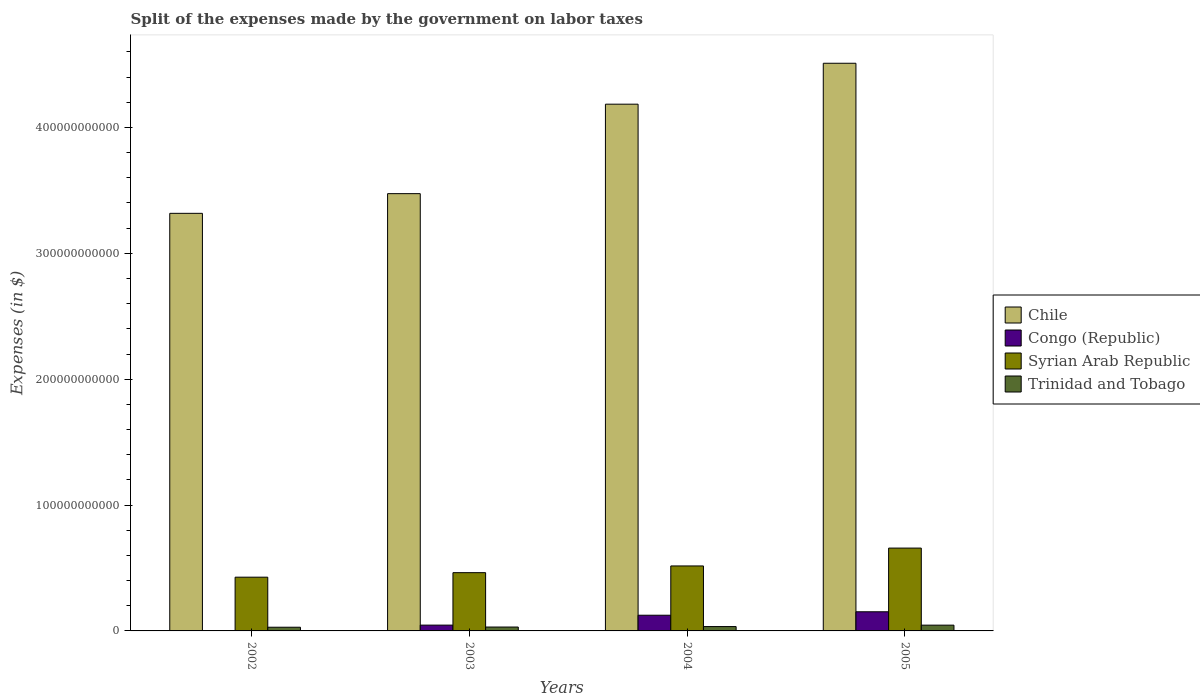How many groups of bars are there?
Give a very brief answer. 4. Are the number of bars on each tick of the X-axis equal?
Provide a succinct answer. Yes. How many bars are there on the 4th tick from the right?
Offer a terse response. 4. In how many cases, is the number of bars for a given year not equal to the number of legend labels?
Make the answer very short. 0. What is the expenses made by the government on labor taxes in Trinidad and Tobago in 2005?
Provide a succinct answer. 4.59e+09. Across all years, what is the maximum expenses made by the government on labor taxes in Chile?
Your answer should be very brief. 4.51e+11. Across all years, what is the minimum expenses made by the government on labor taxes in Syrian Arab Republic?
Your response must be concise. 4.27e+1. In which year was the expenses made by the government on labor taxes in Syrian Arab Republic minimum?
Offer a very short reply. 2002. What is the total expenses made by the government on labor taxes in Trinidad and Tobago in the graph?
Give a very brief answer. 1.41e+1. What is the difference between the expenses made by the government on labor taxes in Congo (Republic) in 2002 and that in 2005?
Keep it short and to the point. -1.49e+1. What is the difference between the expenses made by the government on labor taxes in Chile in 2003 and the expenses made by the government on labor taxes in Trinidad and Tobago in 2004?
Your answer should be compact. 3.44e+11. What is the average expenses made by the government on labor taxes in Syrian Arab Republic per year?
Your answer should be very brief. 5.16e+1. In the year 2004, what is the difference between the expenses made by the government on labor taxes in Congo (Republic) and expenses made by the government on labor taxes in Syrian Arab Republic?
Your answer should be very brief. -3.92e+1. In how many years, is the expenses made by the government on labor taxes in Trinidad and Tobago greater than 300000000000 $?
Make the answer very short. 0. What is the ratio of the expenses made by the government on labor taxes in Trinidad and Tobago in 2004 to that in 2005?
Provide a short and direct response. 0.75. Is the expenses made by the government on labor taxes in Chile in 2002 less than that in 2003?
Your answer should be very brief. Yes. What is the difference between the highest and the second highest expenses made by the government on labor taxes in Syrian Arab Republic?
Offer a terse response. 1.42e+1. What is the difference between the highest and the lowest expenses made by the government on labor taxes in Trinidad and Tobago?
Give a very brief answer. 1.66e+09. In how many years, is the expenses made by the government on labor taxes in Trinidad and Tobago greater than the average expenses made by the government on labor taxes in Trinidad and Tobago taken over all years?
Make the answer very short. 1. Is it the case that in every year, the sum of the expenses made by the government on labor taxes in Chile and expenses made by the government on labor taxes in Congo (Republic) is greater than the sum of expenses made by the government on labor taxes in Trinidad and Tobago and expenses made by the government on labor taxes in Syrian Arab Republic?
Keep it short and to the point. Yes. What does the 4th bar from the left in 2005 represents?
Provide a succinct answer. Trinidad and Tobago. What does the 1st bar from the right in 2005 represents?
Your response must be concise. Trinidad and Tobago. Are all the bars in the graph horizontal?
Give a very brief answer. No. What is the difference between two consecutive major ticks on the Y-axis?
Offer a terse response. 1.00e+11. Are the values on the major ticks of Y-axis written in scientific E-notation?
Your answer should be very brief. No. Does the graph contain any zero values?
Ensure brevity in your answer.  No. Where does the legend appear in the graph?
Ensure brevity in your answer.  Center right. What is the title of the graph?
Your answer should be compact. Split of the expenses made by the government on labor taxes. Does "South Asia" appear as one of the legend labels in the graph?
Keep it short and to the point. No. What is the label or title of the X-axis?
Make the answer very short. Years. What is the label or title of the Y-axis?
Give a very brief answer. Expenses (in $). What is the Expenses (in $) of Chile in 2002?
Your answer should be compact. 3.32e+11. What is the Expenses (in $) of Congo (Republic) in 2002?
Provide a succinct answer. 3.12e+08. What is the Expenses (in $) of Syrian Arab Republic in 2002?
Ensure brevity in your answer.  4.27e+1. What is the Expenses (in $) of Trinidad and Tobago in 2002?
Your answer should be very brief. 2.93e+09. What is the Expenses (in $) of Chile in 2003?
Give a very brief answer. 3.47e+11. What is the Expenses (in $) of Congo (Republic) in 2003?
Provide a succinct answer. 4.61e+09. What is the Expenses (in $) in Syrian Arab Republic in 2003?
Your answer should be very brief. 4.63e+1. What is the Expenses (in $) in Trinidad and Tobago in 2003?
Offer a terse response. 3.09e+09. What is the Expenses (in $) in Chile in 2004?
Make the answer very short. 4.18e+11. What is the Expenses (in $) in Congo (Republic) in 2004?
Your answer should be compact. 1.25e+1. What is the Expenses (in $) of Syrian Arab Republic in 2004?
Your answer should be compact. 5.16e+1. What is the Expenses (in $) in Trinidad and Tobago in 2004?
Keep it short and to the point. 3.46e+09. What is the Expenses (in $) in Chile in 2005?
Provide a short and direct response. 4.51e+11. What is the Expenses (in $) of Congo (Republic) in 2005?
Give a very brief answer. 1.52e+1. What is the Expenses (in $) in Syrian Arab Republic in 2005?
Give a very brief answer. 6.58e+1. What is the Expenses (in $) in Trinidad and Tobago in 2005?
Provide a short and direct response. 4.59e+09. Across all years, what is the maximum Expenses (in $) in Chile?
Your response must be concise. 4.51e+11. Across all years, what is the maximum Expenses (in $) in Congo (Republic)?
Your answer should be very brief. 1.52e+1. Across all years, what is the maximum Expenses (in $) in Syrian Arab Republic?
Provide a short and direct response. 6.58e+1. Across all years, what is the maximum Expenses (in $) of Trinidad and Tobago?
Your answer should be very brief. 4.59e+09. Across all years, what is the minimum Expenses (in $) in Chile?
Give a very brief answer. 3.32e+11. Across all years, what is the minimum Expenses (in $) in Congo (Republic)?
Offer a very short reply. 3.12e+08. Across all years, what is the minimum Expenses (in $) in Syrian Arab Republic?
Make the answer very short. 4.27e+1. Across all years, what is the minimum Expenses (in $) in Trinidad and Tobago?
Your answer should be very brief. 2.93e+09. What is the total Expenses (in $) of Chile in the graph?
Offer a terse response. 1.55e+12. What is the total Expenses (in $) of Congo (Republic) in the graph?
Make the answer very short. 3.26e+1. What is the total Expenses (in $) in Syrian Arab Republic in the graph?
Your answer should be compact. 2.06e+11. What is the total Expenses (in $) in Trinidad and Tobago in the graph?
Keep it short and to the point. 1.41e+1. What is the difference between the Expenses (in $) of Chile in 2002 and that in 2003?
Ensure brevity in your answer.  -1.56e+1. What is the difference between the Expenses (in $) of Congo (Republic) in 2002 and that in 2003?
Offer a very short reply. -4.30e+09. What is the difference between the Expenses (in $) of Syrian Arab Republic in 2002 and that in 2003?
Keep it short and to the point. -3.59e+09. What is the difference between the Expenses (in $) in Trinidad and Tobago in 2002 and that in 2003?
Your answer should be very brief. -1.53e+08. What is the difference between the Expenses (in $) in Chile in 2002 and that in 2004?
Give a very brief answer. -8.67e+1. What is the difference between the Expenses (in $) in Congo (Republic) in 2002 and that in 2004?
Offer a very short reply. -1.22e+1. What is the difference between the Expenses (in $) of Syrian Arab Republic in 2002 and that in 2004?
Keep it short and to the point. -8.93e+09. What is the difference between the Expenses (in $) in Trinidad and Tobago in 2002 and that in 2004?
Your answer should be compact. -5.26e+08. What is the difference between the Expenses (in $) in Chile in 2002 and that in 2005?
Your answer should be very brief. -1.19e+11. What is the difference between the Expenses (in $) in Congo (Republic) in 2002 and that in 2005?
Your response must be concise. -1.49e+1. What is the difference between the Expenses (in $) in Syrian Arab Republic in 2002 and that in 2005?
Your answer should be compact. -2.31e+1. What is the difference between the Expenses (in $) in Trinidad and Tobago in 2002 and that in 2005?
Your answer should be very brief. -1.66e+09. What is the difference between the Expenses (in $) in Chile in 2003 and that in 2004?
Your answer should be very brief. -7.11e+1. What is the difference between the Expenses (in $) of Congo (Republic) in 2003 and that in 2004?
Keep it short and to the point. -7.85e+09. What is the difference between the Expenses (in $) in Syrian Arab Republic in 2003 and that in 2004?
Make the answer very short. -5.34e+09. What is the difference between the Expenses (in $) of Trinidad and Tobago in 2003 and that in 2004?
Offer a terse response. -3.72e+08. What is the difference between the Expenses (in $) in Chile in 2003 and that in 2005?
Your answer should be compact. -1.04e+11. What is the difference between the Expenses (in $) of Congo (Republic) in 2003 and that in 2005?
Ensure brevity in your answer.  -1.06e+1. What is the difference between the Expenses (in $) in Syrian Arab Republic in 2003 and that in 2005?
Provide a short and direct response. -1.95e+1. What is the difference between the Expenses (in $) in Trinidad and Tobago in 2003 and that in 2005?
Keep it short and to the point. -1.50e+09. What is the difference between the Expenses (in $) of Chile in 2004 and that in 2005?
Keep it short and to the point. -3.25e+1. What is the difference between the Expenses (in $) in Congo (Republic) in 2004 and that in 2005?
Provide a short and direct response. -2.75e+09. What is the difference between the Expenses (in $) of Syrian Arab Republic in 2004 and that in 2005?
Your answer should be compact. -1.42e+1. What is the difference between the Expenses (in $) of Trinidad and Tobago in 2004 and that in 2005?
Give a very brief answer. -1.13e+09. What is the difference between the Expenses (in $) of Chile in 2002 and the Expenses (in $) of Congo (Republic) in 2003?
Your answer should be very brief. 3.27e+11. What is the difference between the Expenses (in $) in Chile in 2002 and the Expenses (in $) in Syrian Arab Republic in 2003?
Provide a succinct answer. 2.85e+11. What is the difference between the Expenses (in $) of Chile in 2002 and the Expenses (in $) of Trinidad and Tobago in 2003?
Ensure brevity in your answer.  3.29e+11. What is the difference between the Expenses (in $) in Congo (Republic) in 2002 and the Expenses (in $) in Syrian Arab Republic in 2003?
Give a very brief answer. -4.60e+1. What is the difference between the Expenses (in $) in Congo (Republic) in 2002 and the Expenses (in $) in Trinidad and Tobago in 2003?
Give a very brief answer. -2.78e+09. What is the difference between the Expenses (in $) in Syrian Arab Republic in 2002 and the Expenses (in $) in Trinidad and Tobago in 2003?
Make the answer very short. 3.96e+1. What is the difference between the Expenses (in $) of Chile in 2002 and the Expenses (in $) of Congo (Republic) in 2004?
Make the answer very short. 3.19e+11. What is the difference between the Expenses (in $) of Chile in 2002 and the Expenses (in $) of Syrian Arab Republic in 2004?
Your answer should be compact. 2.80e+11. What is the difference between the Expenses (in $) of Chile in 2002 and the Expenses (in $) of Trinidad and Tobago in 2004?
Offer a terse response. 3.28e+11. What is the difference between the Expenses (in $) of Congo (Republic) in 2002 and the Expenses (in $) of Syrian Arab Republic in 2004?
Provide a succinct answer. -5.13e+1. What is the difference between the Expenses (in $) of Congo (Republic) in 2002 and the Expenses (in $) of Trinidad and Tobago in 2004?
Offer a terse response. -3.15e+09. What is the difference between the Expenses (in $) in Syrian Arab Republic in 2002 and the Expenses (in $) in Trinidad and Tobago in 2004?
Your answer should be compact. 3.92e+1. What is the difference between the Expenses (in $) of Chile in 2002 and the Expenses (in $) of Congo (Republic) in 2005?
Keep it short and to the point. 3.17e+11. What is the difference between the Expenses (in $) in Chile in 2002 and the Expenses (in $) in Syrian Arab Republic in 2005?
Provide a succinct answer. 2.66e+11. What is the difference between the Expenses (in $) of Chile in 2002 and the Expenses (in $) of Trinidad and Tobago in 2005?
Your answer should be compact. 3.27e+11. What is the difference between the Expenses (in $) of Congo (Republic) in 2002 and the Expenses (in $) of Syrian Arab Republic in 2005?
Your response must be concise. -6.55e+1. What is the difference between the Expenses (in $) of Congo (Republic) in 2002 and the Expenses (in $) of Trinidad and Tobago in 2005?
Ensure brevity in your answer.  -4.28e+09. What is the difference between the Expenses (in $) of Syrian Arab Republic in 2002 and the Expenses (in $) of Trinidad and Tobago in 2005?
Give a very brief answer. 3.81e+1. What is the difference between the Expenses (in $) in Chile in 2003 and the Expenses (in $) in Congo (Republic) in 2004?
Your response must be concise. 3.35e+11. What is the difference between the Expenses (in $) of Chile in 2003 and the Expenses (in $) of Syrian Arab Republic in 2004?
Provide a succinct answer. 2.96e+11. What is the difference between the Expenses (in $) of Chile in 2003 and the Expenses (in $) of Trinidad and Tobago in 2004?
Your response must be concise. 3.44e+11. What is the difference between the Expenses (in $) of Congo (Republic) in 2003 and the Expenses (in $) of Syrian Arab Republic in 2004?
Keep it short and to the point. -4.70e+1. What is the difference between the Expenses (in $) of Congo (Republic) in 2003 and the Expenses (in $) of Trinidad and Tobago in 2004?
Offer a terse response. 1.15e+09. What is the difference between the Expenses (in $) in Syrian Arab Republic in 2003 and the Expenses (in $) in Trinidad and Tobago in 2004?
Provide a short and direct response. 4.28e+1. What is the difference between the Expenses (in $) in Chile in 2003 and the Expenses (in $) in Congo (Republic) in 2005?
Offer a terse response. 3.32e+11. What is the difference between the Expenses (in $) in Chile in 2003 and the Expenses (in $) in Syrian Arab Republic in 2005?
Make the answer very short. 2.82e+11. What is the difference between the Expenses (in $) in Chile in 2003 and the Expenses (in $) in Trinidad and Tobago in 2005?
Provide a short and direct response. 3.43e+11. What is the difference between the Expenses (in $) of Congo (Republic) in 2003 and the Expenses (in $) of Syrian Arab Republic in 2005?
Ensure brevity in your answer.  -6.12e+1. What is the difference between the Expenses (in $) in Congo (Republic) in 2003 and the Expenses (in $) in Trinidad and Tobago in 2005?
Offer a terse response. 2.38e+07. What is the difference between the Expenses (in $) in Syrian Arab Republic in 2003 and the Expenses (in $) in Trinidad and Tobago in 2005?
Keep it short and to the point. 4.17e+1. What is the difference between the Expenses (in $) in Chile in 2004 and the Expenses (in $) in Congo (Republic) in 2005?
Keep it short and to the point. 4.03e+11. What is the difference between the Expenses (in $) in Chile in 2004 and the Expenses (in $) in Syrian Arab Republic in 2005?
Your response must be concise. 3.53e+11. What is the difference between the Expenses (in $) in Chile in 2004 and the Expenses (in $) in Trinidad and Tobago in 2005?
Your answer should be compact. 4.14e+11. What is the difference between the Expenses (in $) in Congo (Republic) in 2004 and the Expenses (in $) in Syrian Arab Republic in 2005?
Provide a short and direct response. -5.33e+1. What is the difference between the Expenses (in $) in Congo (Republic) in 2004 and the Expenses (in $) in Trinidad and Tobago in 2005?
Keep it short and to the point. 7.87e+09. What is the difference between the Expenses (in $) in Syrian Arab Republic in 2004 and the Expenses (in $) in Trinidad and Tobago in 2005?
Your answer should be compact. 4.70e+1. What is the average Expenses (in $) of Chile per year?
Offer a terse response. 3.87e+11. What is the average Expenses (in $) in Congo (Republic) per year?
Your answer should be very brief. 8.15e+09. What is the average Expenses (in $) in Syrian Arab Republic per year?
Provide a succinct answer. 5.16e+1. What is the average Expenses (in $) in Trinidad and Tobago per year?
Offer a terse response. 3.52e+09. In the year 2002, what is the difference between the Expenses (in $) of Chile and Expenses (in $) of Congo (Republic)?
Give a very brief answer. 3.31e+11. In the year 2002, what is the difference between the Expenses (in $) in Chile and Expenses (in $) in Syrian Arab Republic?
Your answer should be compact. 2.89e+11. In the year 2002, what is the difference between the Expenses (in $) in Chile and Expenses (in $) in Trinidad and Tobago?
Your answer should be very brief. 3.29e+11. In the year 2002, what is the difference between the Expenses (in $) of Congo (Republic) and Expenses (in $) of Syrian Arab Republic?
Your answer should be very brief. -4.24e+1. In the year 2002, what is the difference between the Expenses (in $) of Congo (Republic) and Expenses (in $) of Trinidad and Tobago?
Provide a succinct answer. -2.62e+09. In the year 2002, what is the difference between the Expenses (in $) in Syrian Arab Republic and Expenses (in $) in Trinidad and Tobago?
Provide a short and direct response. 3.98e+1. In the year 2003, what is the difference between the Expenses (in $) in Chile and Expenses (in $) in Congo (Republic)?
Provide a succinct answer. 3.43e+11. In the year 2003, what is the difference between the Expenses (in $) of Chile and Expenses (in $) of Syrian Arab Republic?
Provide a short and direct response. 3.01e+11. In the year 2003, what is the difference between the Expenses (in $) in Chile and Expenses (in $) in Trinidad and Tobago?
Make the answer very short. 3.44e+11. In the year 2003, what is the difference between the Expenses (in $) of Congo (Republic) and Expenses (in $) of Syrian Arab Republic?
Ensure brevity in your answer.  -4.17e+1. In the year 2003, what is the difference between the Expenses (in $) of Congo (Republic) and Expenses (in $) of Trinidad and Tobago?
Provide a succinct answer. 1.53e+09. In the year 2003, what is the difference between the Expenses (in $) of Syrian Arab Republic and Expenses (in $) of Trinidad and Tobago?
Make the answer very short. 4.32e+1. In the year 2004, what is the difference between the Expenses (in $) of Chile and Expenses (in $) of Congo (Republic)?
Ensure brevity in your answer.  4.06e+11. In the year 2004, what is the difference between the Expenses (in $) of Chile and Expenses (in $) of Syrian Arab Republic?
Your answer should be compact. 3.67e+11. In the year 2004, what is the difference between the Expenses (in $) of Chile and Expenses (in $) of Trinidad and Tobago?
Keep it short and to the point. 4.15e+11. In the year 2004, what is the difference between the Expenses (in $) in Congo (Republic) and Expenses (in $) in Syrian Arab Republic?
Your answer should be very brief. -3.92e+1. In the year 2004, what is the difference between the Expenses (in $) in Congo (Republic) and Expenses (in $) in Trinidad and Tobago?
Provide a succinct answer. 9.00e+09. In the year 2004, what is the difference between the Expenses (in $) in Syrian Arab Republic and Expenses (in $) in Trinidad and Tobago?
Make the answer very short. 4.82e+1. In the year 2005, what is the difference between the Expenses (in $) in Chile and Expenses (in $) in Congo (Republic)?
Give a very brief answer. 4.36e+11. In the year 2005, what is the difference between the Expenses (in $) of Chile and Expenses (in $) of Syrian Arab Republic?
Provide a short and direct response. 3.85e+11. In the year 2005, what is the difference between the Expenses (in $) of Chile and Expenses (in $) of Trinidad and Tobago?
Keep it short and to the point. 4.46e+11. In the year 2005, what is the difference between the Expenses (in $) in Congo (Republic) and Expenses (in $) in Syrian Arab Republic?
Provide a short and direct response. -5.06e+1. In the year 2005, what is the difference between the Expenses (in $) in Congo (Republic) and Expenses (in $) in Trinidad and Tobago?
Give a very brief answer. 1.06e+1. In the year 2005, what is the difference between the Expenses (in $) in Syrian Arab Republic and Expenses (in $) in Trinidad and Tobago?
Your response must be concise. 6.12e+1. What is the ratio of the Expenses (in $) of Chile in 2002 to that in 2003?
Your response must be concise. 0.95. What is the ratio of the Expenses (in $) of Congo (Republic) in 2002 to that in 2003?
Provide a succinct answer. 0.07. What is the ratio of the Expenses (in $) of Syrian Arab Republic in 2002 to that in 2003?
Your response must be concise. 0.92. What is the ratio of the Expenses (in $) of Trinidad and Tobago in 2002 to that in 2003?
Make the answer very short. 0.95. What is the ratio of the Expenses (in $) in Chile in 2002 to that in 2004?
Keep it short and to the point. 0.79. What is the ratio of the Expenses (in $) of Congo (Republic) in 2002 to that in 2004?
Offer a terse response. 0.03. What is the ratio of the Expenses (in $) of Syrian Arab Republic in 2002 to that in 2004?
Make the answer very short. 0.83. What is the ratio of the Expenses (in $) of Trinidad and Tobago in 2002 to that in 2004?
Give a very brief answer. 0.85. What is the ratio of the Expenses (in $) in Chile in 2002 to that in 2005?
Provide a short and direct response. 0.74. What is the ratio of the Expenses (in $) in Congo (Republic) in 2002 to that in 2005?
Your response must be concise. 0.02. What is the ratio of the Expenses (in $) in Syrian Arab Republic in 2002 to that in 2005?
Offer a terse response. 0.65. What is the ratio of the Expenses (in $) of Trinidad and Tobago in 2002 to that in 2005?
Your response must be concise. 0.64. What is the ratio of the Expenses (in $) in Chile in 2003 to that in 2004?
Make the answer very short. 0.83. What is the ratio of the Expenses (in $) in Congo (Republic) in 2003 to that in 2004?
Ensure brevity in your answer.  0.37. What is the ratio of the Expenses (in $) of Syrian Arab Republic in 2003 to that in 2004?
Your answer should be compact. 0.9. What is the ratio of the Expenses (in $) in Trinidad and Tobago in 2003 to that in 2004?
Offer a terse response. 0.89. What is the ratio of the Expenses (in $) in Chile in 2003 to that in 2005?
Your answer should be compact. 0.77. What is the ratio of the Expenses (in $) in Congo (Republic) in 2003 to that in 2005?
Make the answer very short. 0.3. What is the ratio of the Expenses (in $) in Syrian Arab Republic in 2003 to that in 2005?
Keep it short and to the point. 0.7. What is the ratio of the Expenses (in $) of Trinidad and Tobago in 2003 to that in 2005?
Your response must be concise. 0.67. What is the ratio of the Expenses (in $) in Chile in 2004 to that in 2005?
Make the answer very short. 0.93. What is the ratio of the Expenses (in $) of Congo (Republic) in 2004 to that in 2005?
Provide a succinct answer. 0.82. What is the ratio of the Expenses (in $) in Syrian Arab Republic in 2004 to that in 2005?
Your answer should be compact. 0.78. What is the ratio of the Expenses (in $) of Trinidad and Tobago in 2004 to that in 2005?
Your answer should be very brief. 0.75. What is the difference between the highest and the second highest Expenses (in $) of Chile?
Keep it short and to the point. 3.25e+1. What is the difference between the highest and the second highest Expenses (in $) of Congo (Republic)?
Provide a short and direct response. 2.75e+09. What is the difference between the highest and the second highest Expenses (in $) of Syrian Arab Republic?
Make the answer very short. 1.42e+1. What is the difference between the highest and the second highest Expenses (in $) of Trinidad and Tobago?
Offer a very short reply. 1.13e+09. What is the difference between the highest and the lowest Expenses (in $) in Chile?
Keep it short and to the point. 1.19e+11. What is the difference between the highest and the lowest Expenses (in $) of Congo (Republic)?
Offer a very short reply. 1.49e+1. What is the difference between the highest and the lowest Expenses (in $) in Syrian Arab Republic?
Your response must be concise. 2.31e+1. What is the difference between the highest and the lowest Expenses (in $) in Trinidad and Tobago?
Make the answer very short. 1.66e+09. 